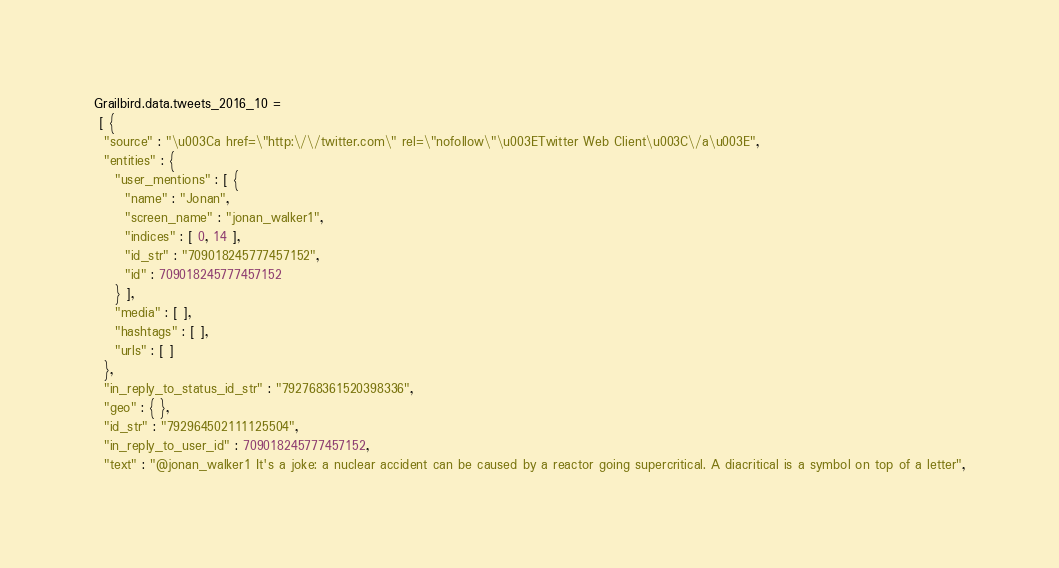Convert code to text. <code><loc_0><loc_0><loc_500><loc_500><_JavaScript_>Grailbird.data.tweets_2016_10 = 
 [ {
  "source" : "\u003Ca href=\"http:\/\/twitter.com\" rel=\"nofollow\"\u003ETwitter Web Client\u003C\/a\u003E",
  "entities" : {
    "user_mentions" : [ {
      "name" : "Jonan",
      "screen_name" : "jonan_walker1",
      "indices" : [ 0, 14 ],
      "id_str" : "709018245777457152",
      "id" : 709018245777457152
    } ],
    "media" : [ ],
    "hashtags" : [ ],
    "urls" : [ ]
  },
  "in_reply_to_status_id_str" : "792768361520398336",
  "geo" : { },
  "id_str" : "792964502111125504",
  "in_reply_to_user_id" : 709018245777457152,
  "text" : "@jonan_walker1 It's a joke: a nuclear accident can be caused by a reactor going supercritical. A diacritical is a symbol on top of a letter",</code> 